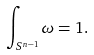Convert formula to latex. <formula><loc_0><loc_0><loc_500><loc_500>\int _ { { S } ^ { n - 1 } } \omega = 1 .</formula> 